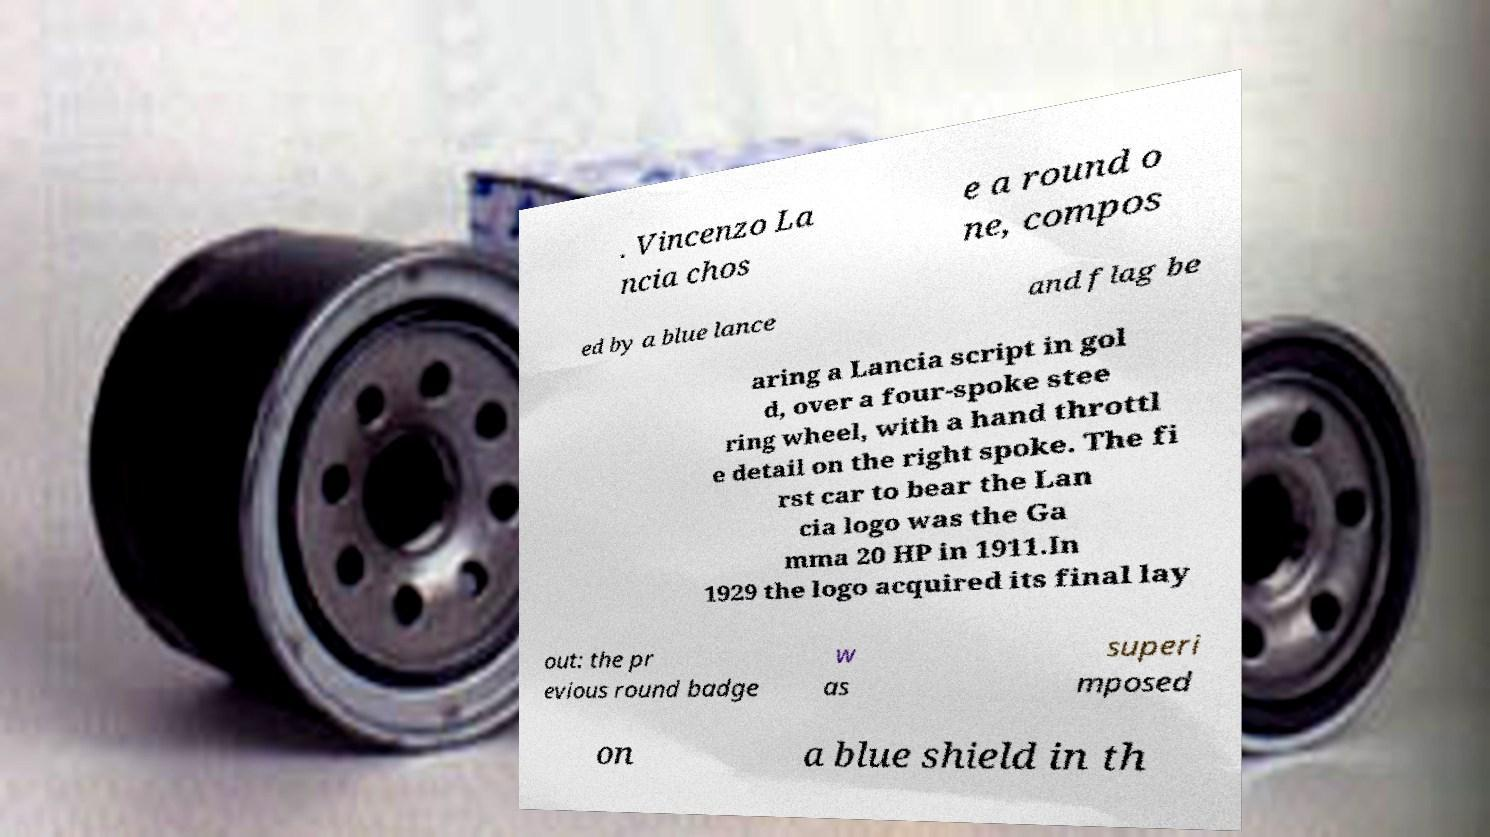There's text embedded in this image that I need extracted. Can you transcribe it verbatim? . Vincenzo La ncia chos e a round o ne, compos ed by a blue lance and flag be aring a Lancia script in gol d, over a four-spoke stee ring wheel, with a hand throttl e detail on the right spoke. The fi rst car to bear the Lan cia logo was the Ga mma 20 HP in 1911.In 1929 the logo acquired its final lay out: the pr evious round badge w as superi mposed on a blue shield in th 